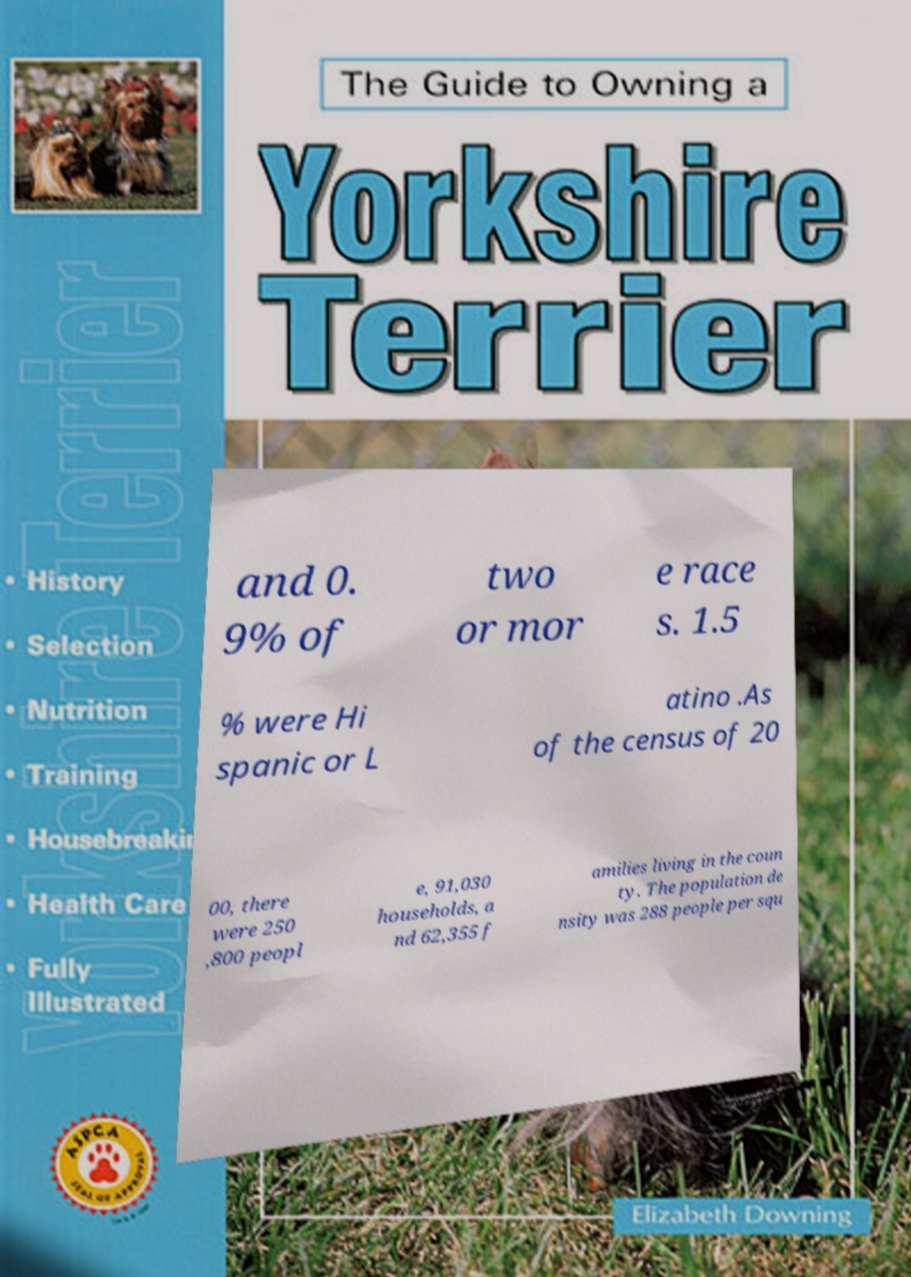Can you accurately transcribe the text from the provided image for me? and 0. 9% of two or mor e race s. 1.5 % were Hi spanic or L atino .As of the census of 20 00, there were 250 ,800 peopl e, 91,030 households, a nd 62,355 f amilies living in the coun ty. The population de nsity was 288 people per squ 